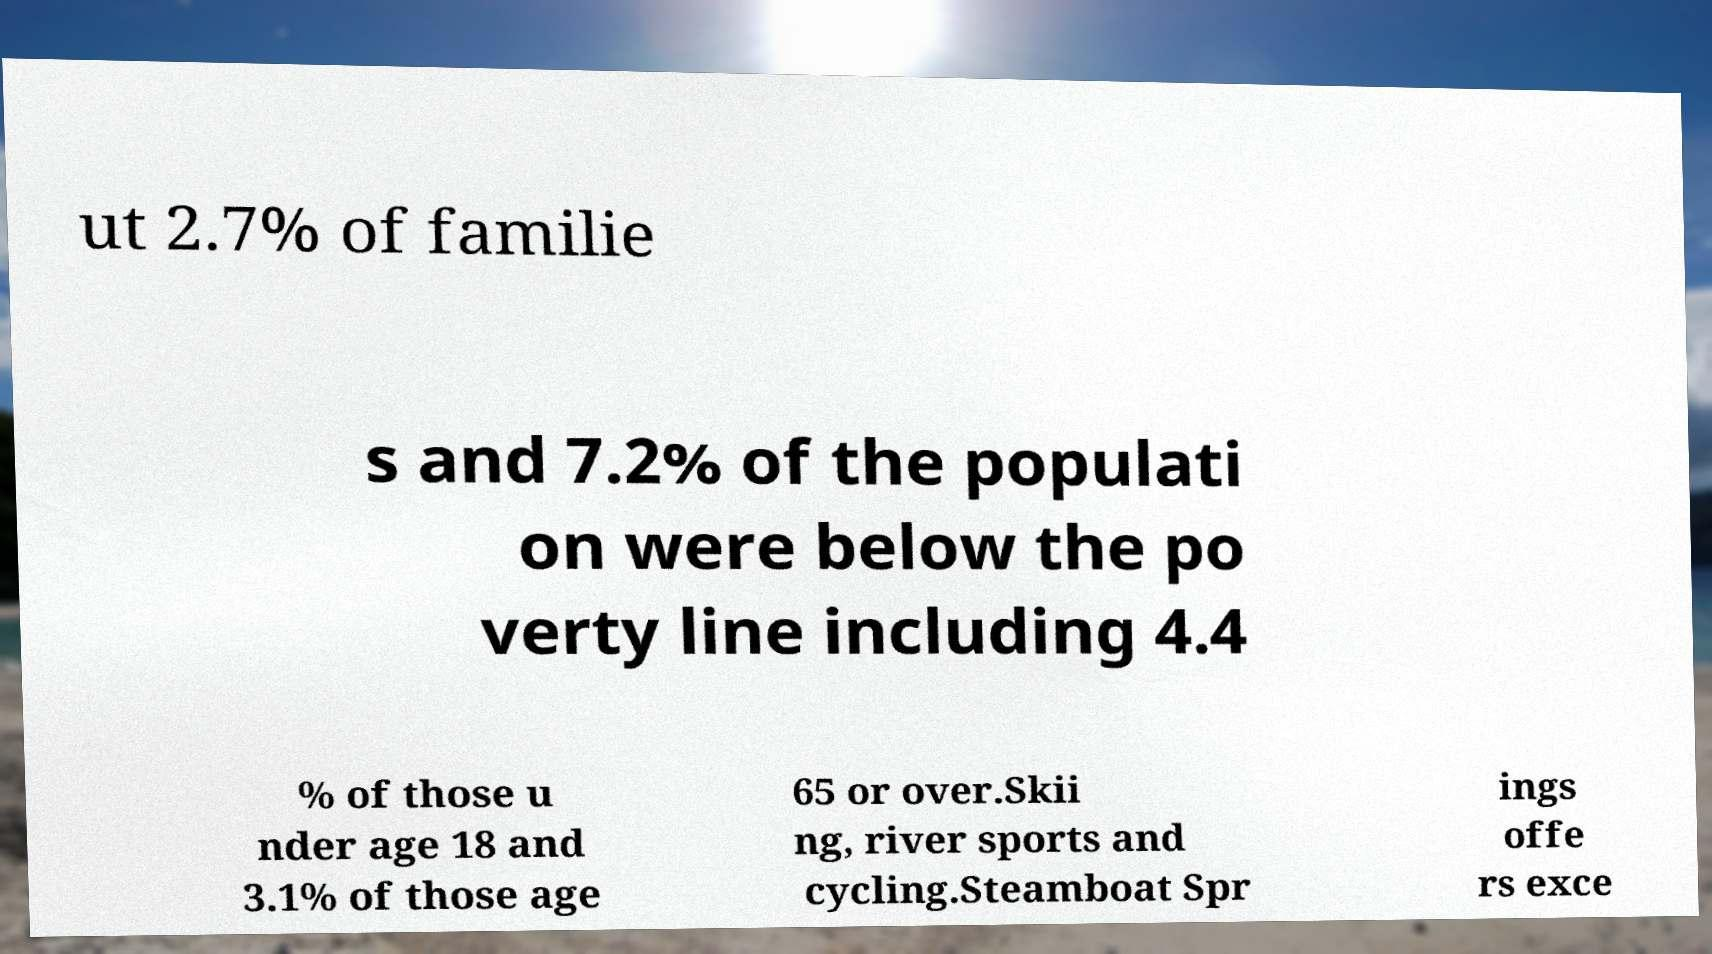Could you extract and type out the text from this image? ut 2.7% of familie s and 7.2% of the populati on were below the po verty line including 4.4 % of those u nder age 18 and 3.1% of those age 65 or over.Skii ng, river sports and cycling.Steamboat Spr ings offe rs exce 